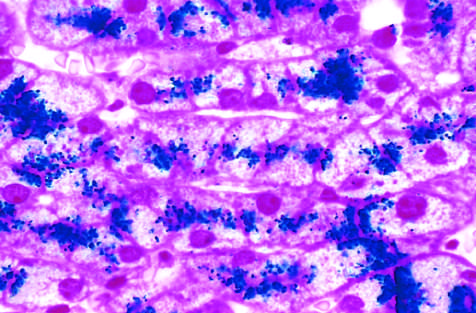re iron deposits shown by a special staining process call the prussian blue reaction?
Answer the question using a single word or phrase. Yes 